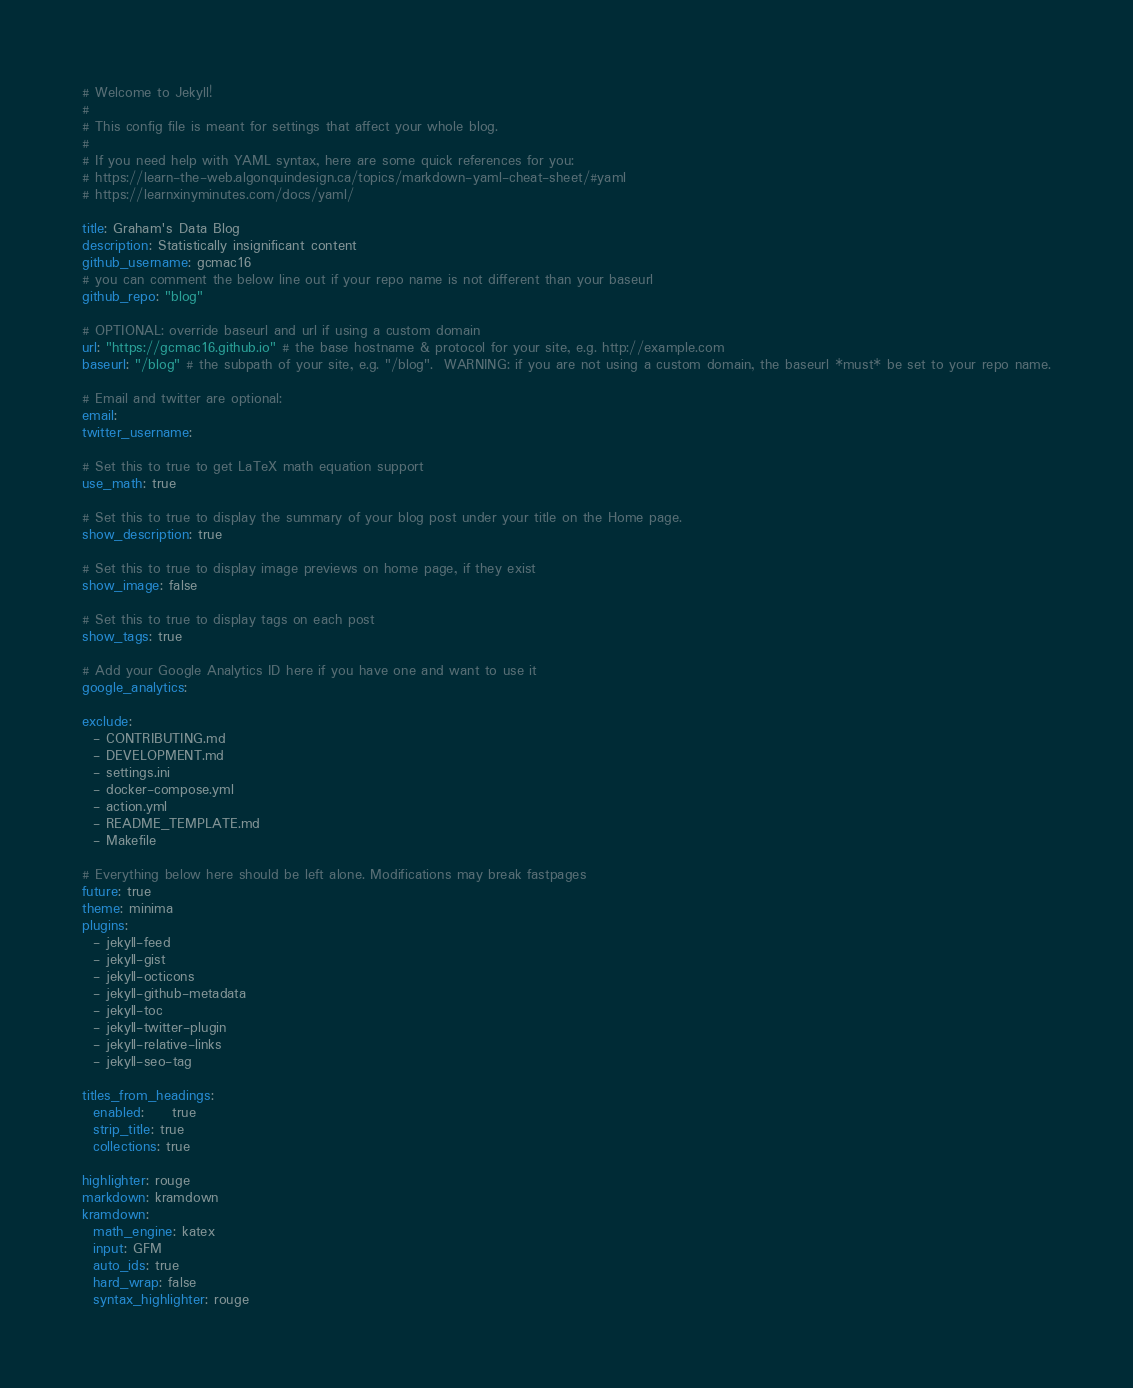Convert code to text. <code><loc_0><loc_0><loc_500><loc_500><_YAML_># Welcome to Jekyll!
#
# This config file is meant for settings that affect your whole blog.
#
# If you need help with YAML syntax, here are some quick references for you: 
# https://learn-the-web.algonquindesign.ca/topics/markdown-yaml-cheat-sheet/#yaml
# https://learnxinyminutes.com/docs/yaml/

title: Graham's Data Blog
description: Statistically insignificant content
github_username: gcmac16
# you can comment the below line out if your repo name is not different than your baseurl
github_repo: "blog"

# OPTIONAL: override baseurl and url if using a custom domain
url: "https://gcmac16.github.io" # the base hostname & protocol for your site, e.g. http://example.com
baseurl: "/blog" # the subpath of your site, e.g. "/blog".  WARNING: if you are not using a custom domain, the baseurl *must* be set to your repo name.

# Email and twitter are optional:
email: 
twitter_username:

# Set this to true to get LaTeX math equation support
use_math: true

# Set this to true to display the summary of your blog post under your title on the Home page.
show_description: true

# Set this to true to display image previews on home page, if they exist
show_image: false

# Set this to true to display tags on each post
show_tags: true

# Add your Google Analytics ID here if you have one and want to use it
google_analytics:

exclude:
  - CONTRIBUTING.md
  - DEVELOPMENT.md
  - settings.ini
  - docker-compose.yml
  - action.yml
  - README_TEMPLATE.md
  - Makefile

# Everything below here should be left alone. Modifications may break fastpages
future: true
theme: minima
plugins:
  - jekyll-feed
  - jekyll-gist
  - jekyll-octicons
  - jekyll-github-metadata
  - jekyll-toc
  - jekyll-twitter-plugin
  - jekyll-relative-links
  - jekyll-seo-tag

titles_from_headings:
  enabled:     true
  strip_title: true
  collections: true

highlighter: rouge
markdown: kramdown
kramdown:
  math_engine: katex
  input: GFM
  auto_ids: true
  hard_wrap: false
  syntax_highlighter: rouge
</code> 